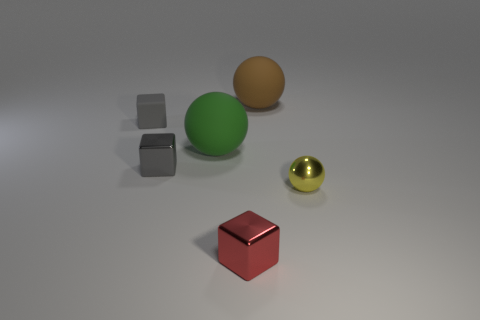Add 2 big yellow cylinders. How many objects exist? 8 Add 4 red metallic things. How many red metallic things exist? 5 Subtract 1 green spheres. How many objects are left? 5 Subtract all gray things. Subtract all red cubes. How many objects are left? 3 Add 6 brown things. How many brown things are left? 7 